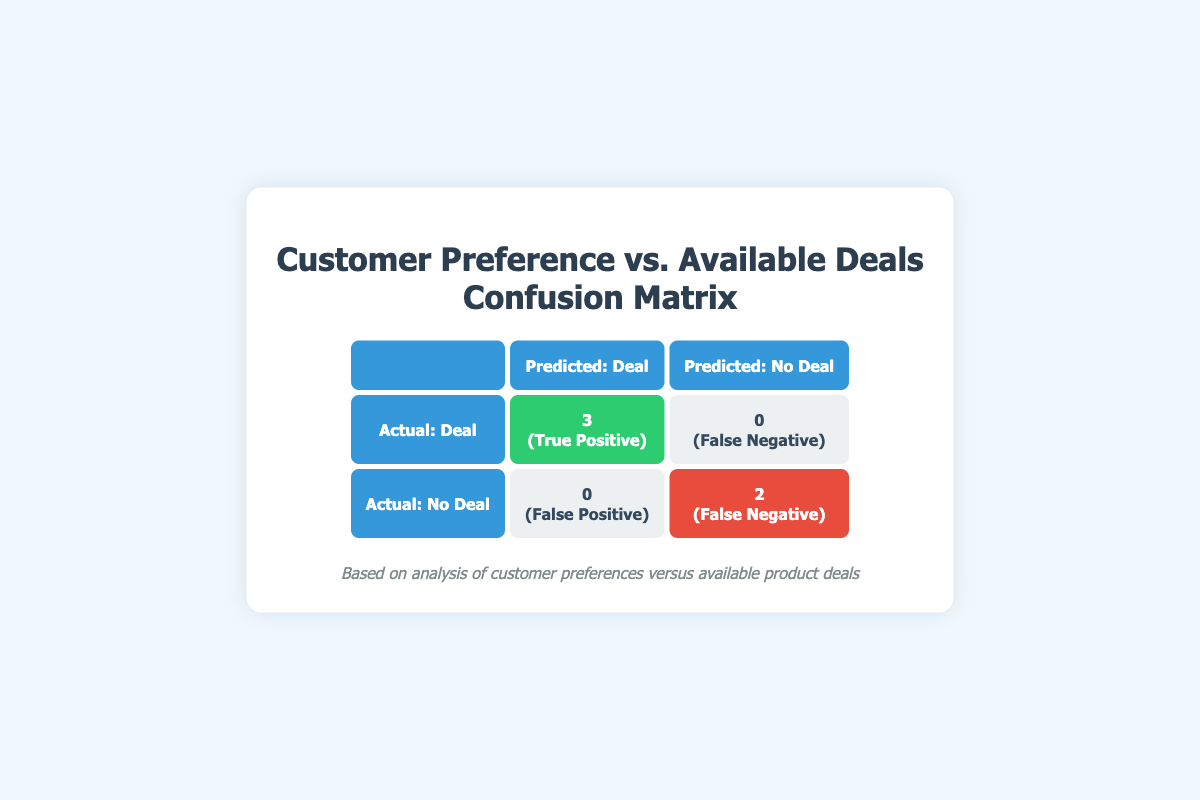What is the count of True Positives in the confusion matrix? In the matrix under the "Actual: Deal" row and "Predicted: Deal" column, there are 3 entries labeled "True Positive."
Answer: 3 How many customers had no deal predicted? From the matrix, the "Actual: No Deal" row has 2 entries under the "Predicted: No Deal" column that are labeled "False Negative." This represents customers who were predicted to have a deal but were actually given no deal.
Answer: 2 What is the total number of customers involved in the analysis? The analysis involves 5 customers, as seen in the customer preferences data.
Answer: 5 Did any customers receive a false positive prediction? A false positive occurs when customers were predicted to have a deal, but in reality, they did not. The matrix shows 0 under "Actual: Deal" and "Predicted: Deal," indicating no false positives.
Answer: No What is the ratio of True Positives to False Negatives? To find the ratio, take the number of True Positives (3) and divide it by the number of False Negatives (2). So, the ratio is 3:2.
Answer: 3:2 How many total different types of deals were available? Analyzing the available deals shows 5 entries, each representing a different deal type. However, some deals were not available, but it still counts as 5 types overall.
Answer: 5 How many deals were unavailable despite being preferred by customers? Looking at the "Actual: Deal" category, there are 0 entries for deals that were unavailable. However, under "Actual: No Deal," two customers preferred Combo Offers and Clearance which were unavailable.
Answer: 2 If a deal is available, what is the probability that a customer will receive a True Positive? True Positives are 3 out of the total predictions (3 True Positives and 2 False Negatives), thus the probability is 3/(3+2), which simplifies to 60% or 0.6.
Answer: 60% What deal type had the highest count of True Positives? The matrix indicates 3 True Positives for the deals (Discount, Buy One Get One, Cashback), each representing the highest count individually, with no deal type exceeding this count.
Answer: Tie between three deal types How many customers were predicted to have deals but actually had no deal? The number of customers predicted to have a deal but had none is found under "Actual: No Deal" and "Predicted: Deal," which is 0.
Answer: 0 